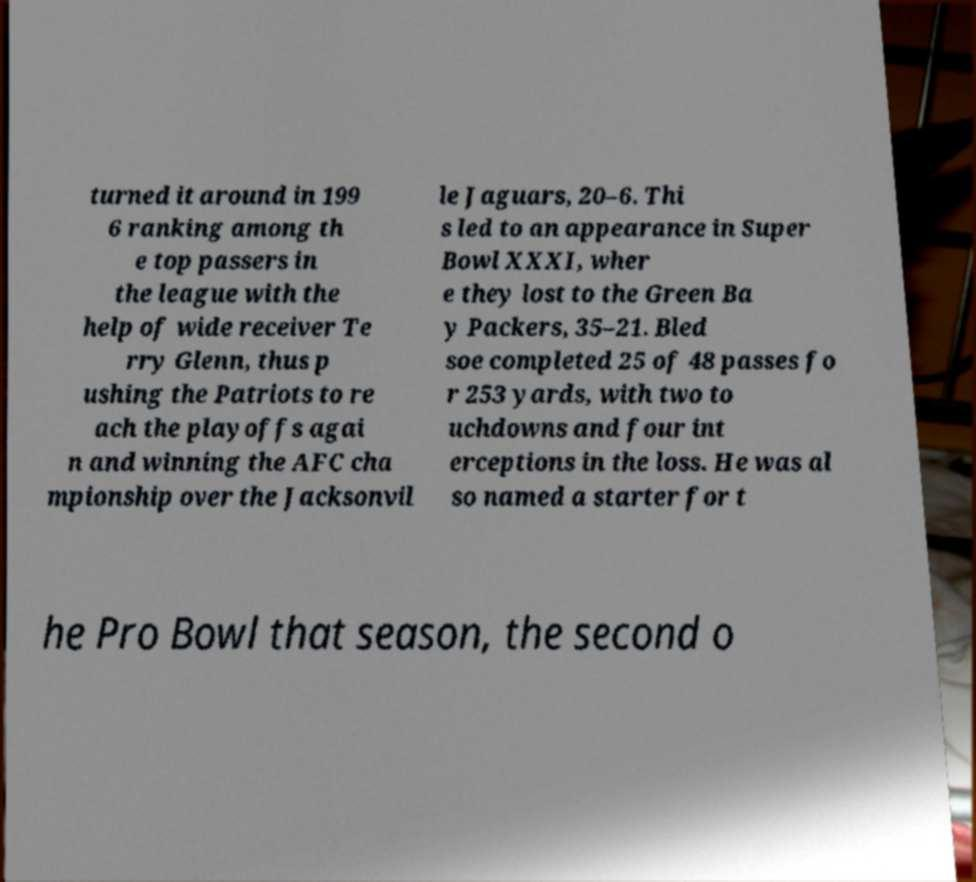Can you read and provide the text displayed in the image?This photo seems to have some interesting text. Can you extract and type it out for me? turned it around in 199 6 ranking among th e top passers in the league with the help of wide receiver Te rry Glenn, thus p ushing the Patriots to re ach the playoffs agai n and winning the AFC cha mpionship over the Jacksonvil le Jaguars, 20–6. Thi s led to an appearance in Super Bowl XXXI, wher e they lost to the Green Ba y Packers, 35–21. Bled soe completed 25 of 48 passes fo r 253 yards, with two to uchdowns and four int erceptions in the loss. He was al so named a starter for t he Pro Bowl that season, the second o 